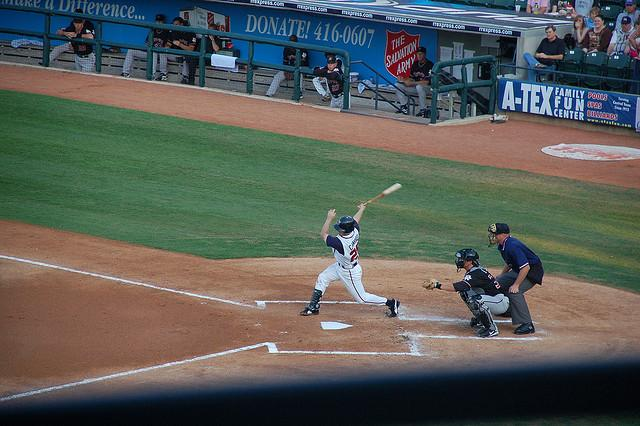Who is the man crouched behind the catcher? Please explain your reasoning. umpire. The men are playing baseball. baseball games require someone to mediate the game. 